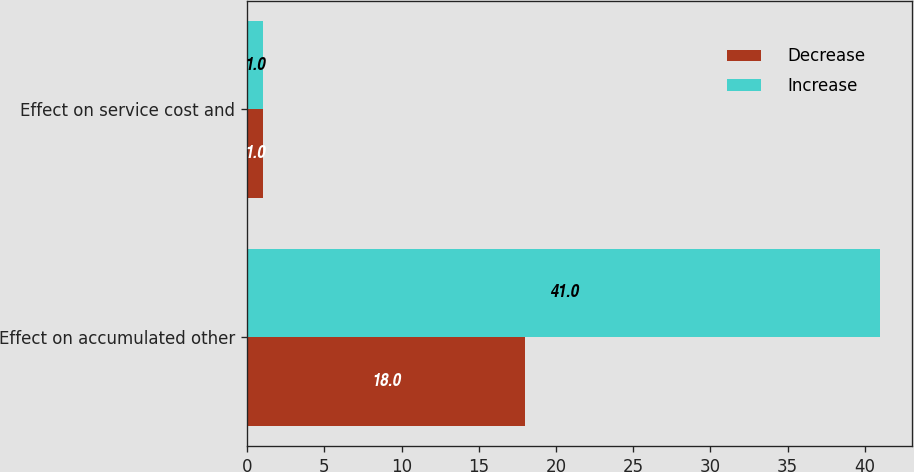Convert chart to OTSL. <chart><loc_0><loc_0><loc_500><loc_500><stacked_bar_chart><ecel><fcel>Effect on accumulated other<fcel>Effect on service cost and<nl><fcel>Decrease<fcel>18<fcel>1<nl><fcel>Increase<fcel>41<fcel>1<nl></chart> 